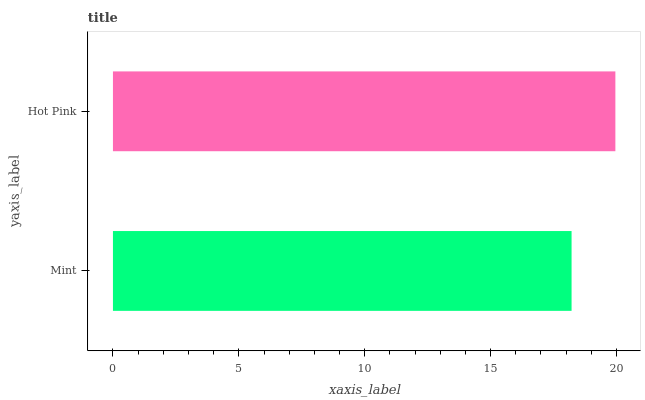Is Mint the minimum?
Answer yes or no. Yes. Is Hot Pink the maximum?
Answer yes or no. Yes. Is Hot Pink the minimum?
Answer yes or no. No. Is Hot Pink greater than Mint?
Answer yes or no. Yes. Is Mint less than Hot Pink?
Answer yes or no. Yes. Is Mint greater than Hot Pink?
Answer yes or no. No. Is Hot Pink less than Mint?
Answer yes or no. No. Is Hot Pink the high median?
Answer yes or no. Yes. Is Mint the low median?
Answer yes or no. Yes. Is Mint the high median?
Answer yes or no. No. Is Hot Pink the low median?
Answer yes or no. No. 